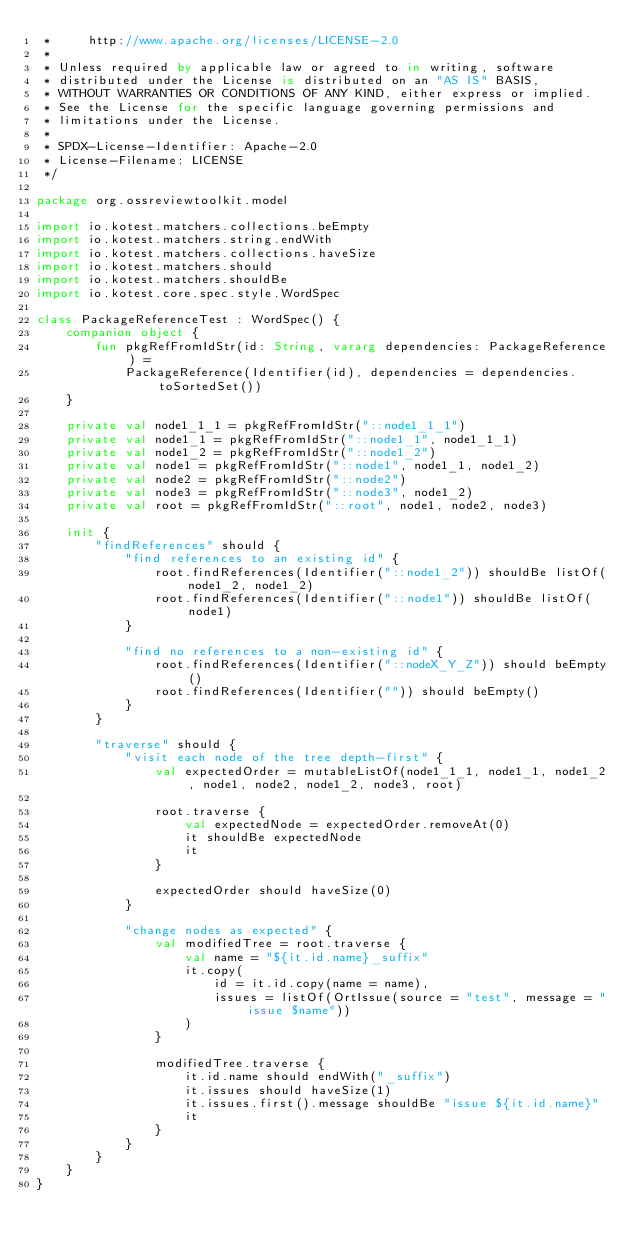<code> <loc_0><loc_0><loc_500><loc_500><_Kotlin_> *     http://www.apache.org/licenses/LICENSE-2.0
 *
 * Unless required by applicable law or agreed to in writing, software
 * distributed under the License is distributed on an "AS IS" BASIS,
 * WITHOUT WARRANTIES OR CONDITIONS OF ANY KIND, either express or implied.
 * See the License for the specific language governing permissions and
 * limitations under the License.
 *
 * SPDX-License-Identifier: Apache-2.0
 * License-Filename: LICENSE
 */

package org.ossreviewtoolkit.model

import io.kotest.matchers.collections.beEmpty
import io.kotest.matchers.string.endWith
import io.kotest.matchers.collections.haveSize
import io.kotest.matchers.should
import io.kotest.matchers.shouldBe
import io.kotest.core.spec.style.WordSpec

class PackageReferenceTest : WordSpec() {
    companion object {
        fun pkgRefFromIdStr(id: String, vararg dependencies: PackageReference) =
            PackageReference(Identifier(id), dependencies = dependencies.toSortedSet())
    }

    private val node1_1_1 = pkgRefFromIdStr("::node1_1_1")
    private val node1_1 = pkgRefFromIdStr("::node1_1", node1_1_1)
    private val node1_2 = pkgRefFromIdStr("::node1_2")
    private val node1 = pkgRefFromIdStr("::node1", node1_1, node1_2)
    private val node2 = pkgRefFromIdStr("::node2")
    private val node3 = pkgRefFromIdStr("::node3", node1_2)
    private val root = pkgRefFromIdStr("::root", node1, node2, node3)

    init {
        "findReferences" should {
            "find references to an existing id" {
                root.findReferences(Identifier("::node1_2")) shouldBe listOf(node1_2, node1_2)
                root.findReferences(Identifier("::node1")) shouldBe listOf(node1)
            }

            "find no references to a non-existing id" {
                root.findReferences(Identifier("::nodeX_Y_Z")) should beEmpty()
                root.findReferences(Identifier("")) should beEmpty()
            }
        }

        "traverse" should {
            "visit each node of the tree depth-first" {
                val expectedOrder = mutableListOf(node1_1_1, node1_1, node1_2, node1, node2, node1_2, node3, root)

                root.traverse {
                    val expectedNode = expectedOrder.removeAt(0)
                    it shouldBe expectedNode
                    it
                }

                expectedOrder should haveSize(0)
            }

            "change nodes as expected" {
                val modifiedTree = root.traverse {
                    val name = "${it.id.name}_suffix"
                    it.copy(
                        id = it.id.copy(name = name),
                        issues = listOf(OrtIssue(source = "test", message = "issue $name"))
                    )
                }

                modifiedTree.traverse {
                    it.id.name should endWith("_suffix")
                    it.issues should haveSize(1)
                    it.issues.first().message shouldBe "issue ${it.id.name}"
                    it
                }
            }
        }
    }
}
</code> 